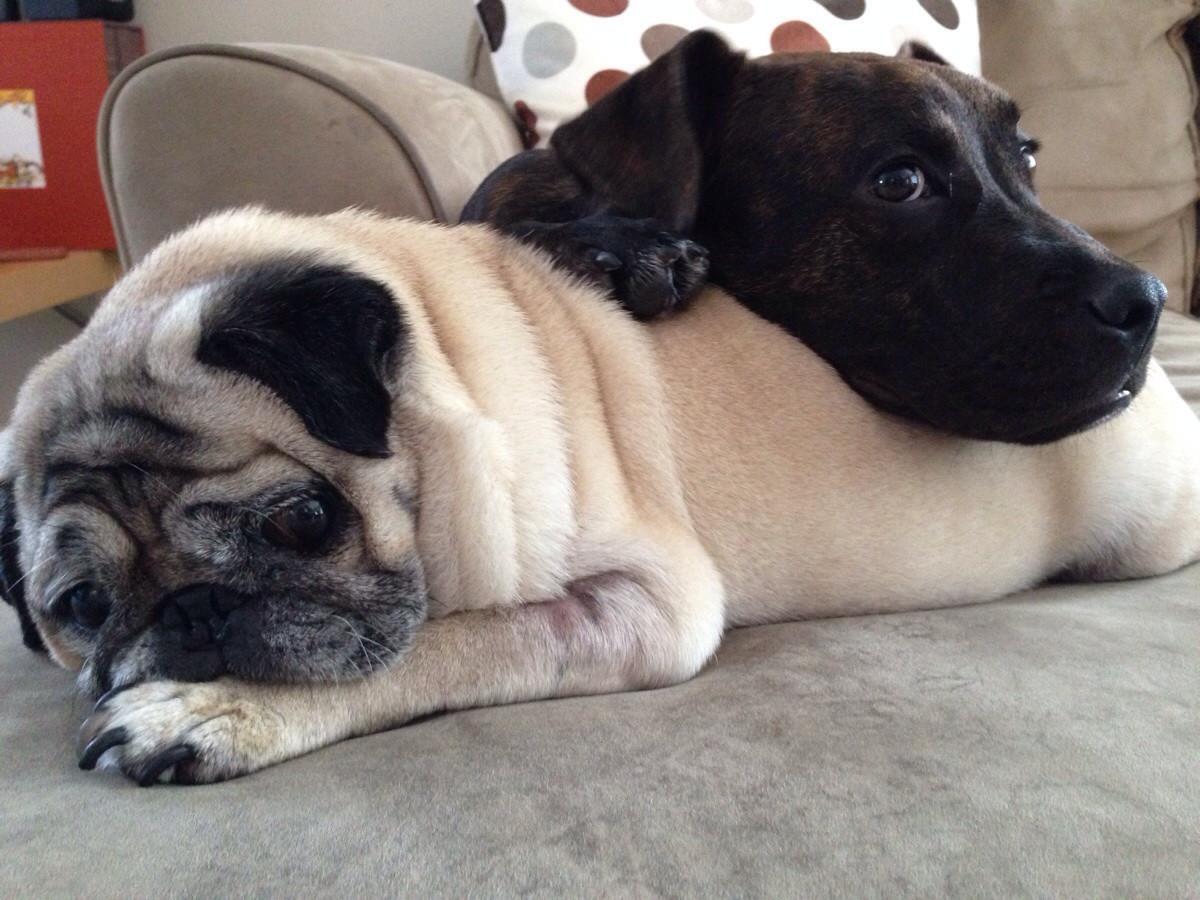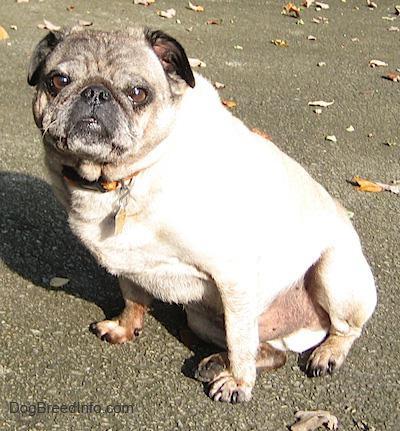The first image is the image on the left, the second image is the image on the right. Considering the images on both sides, is "A pug with a dark muzzle is sleeping on a blanket and in contact with something beige and plush in the left image." valid? Answer yes or no. No. The first image is the image on the left, the second image is the image on the right. Considering the images on both sides, is "There is at least one pug wearing a collar with red in it." valid? Answer yes or no. No. 